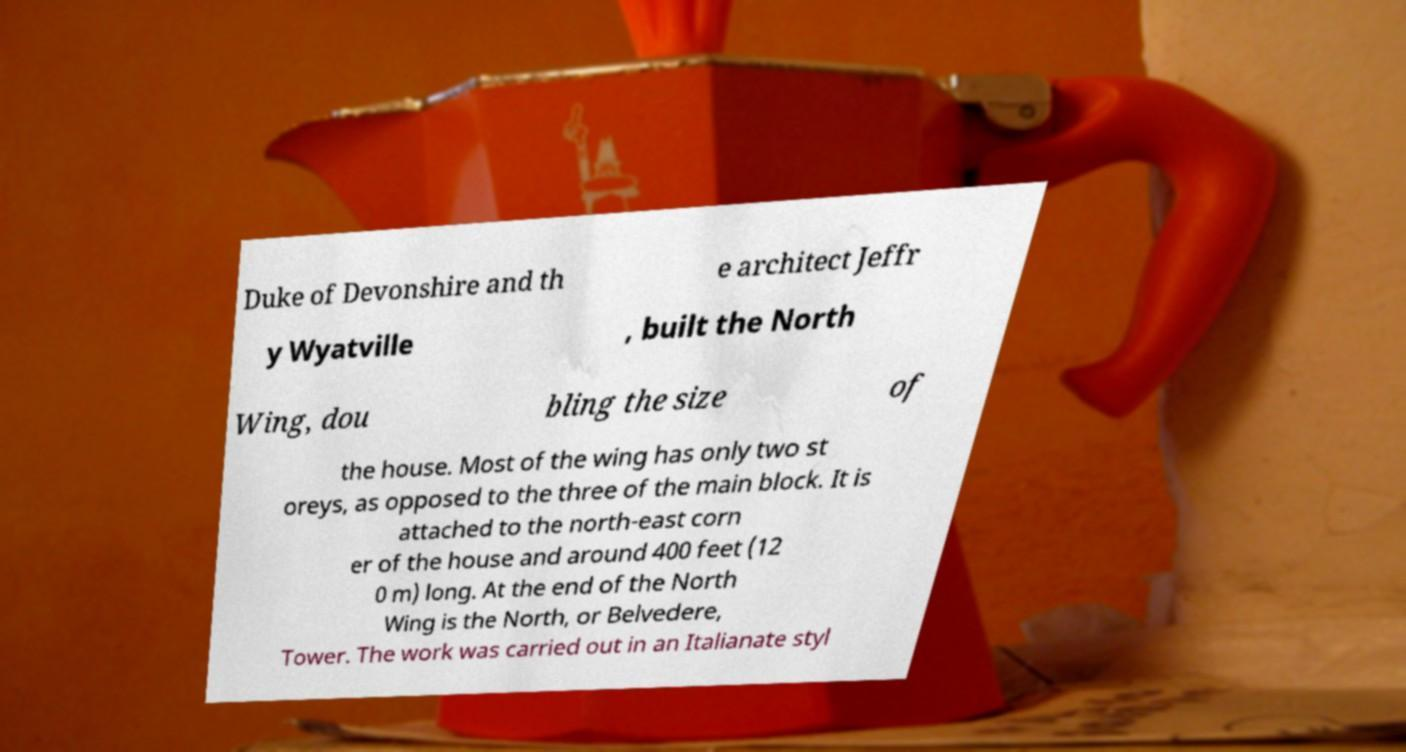What messages or text are displayed in this image? I need them in a readable, typed format. Duke of Devonshire and th e architect Jeffr y Wyatville , built the North Wing, dou bling the size of the house. Most of the wing has only two st oreys, as opposed to the three of the main block. It is attached to the north-east corn er of the house and around 400 feet (12 0 m) long. At the end of the North Wing is the North, or Belvedere, Tower. The work was carried out in an Italianate styl 